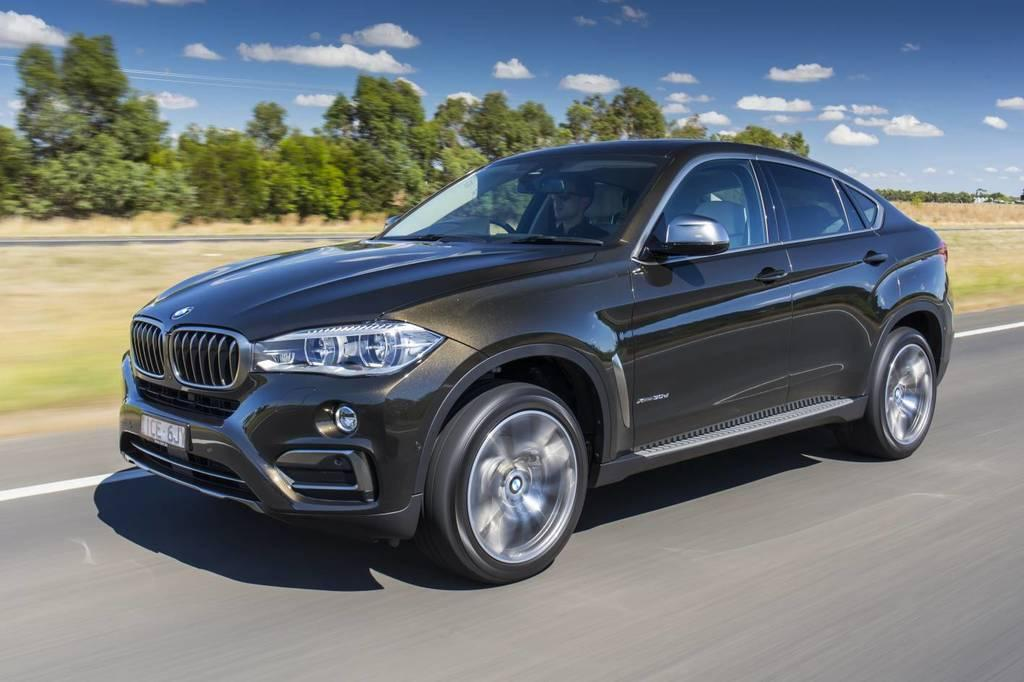What is the main subject in the foreground of the image? There is a car in the foreground of the image. What is the car doing in the image? The car is moving on the road. What type of natural environment can be seen in the background of the image? There is grassland and trees in the background of the image. What else is visible in the background of the image? The sky is visible in the background of the image. How many brushes are used to paint the car in the image? There are no brushes or painting activity depicted in the image; it shows a car moving on the road. 